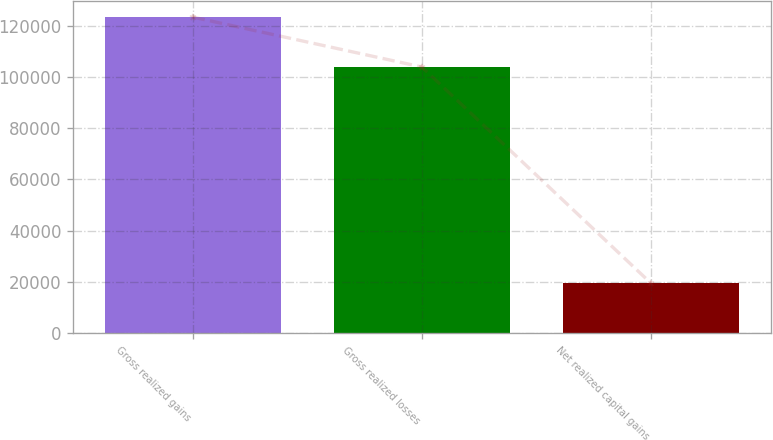Convert chart. <chart><loc_0><loc_0><loc_500><loc_500><bar_chart><fcel>Gross realized gains<fcel>Gross realized losses<fcel>Net realized capital gains<nl><fcel>123361<fcel>103878<fcel>19483<nl></chart> 